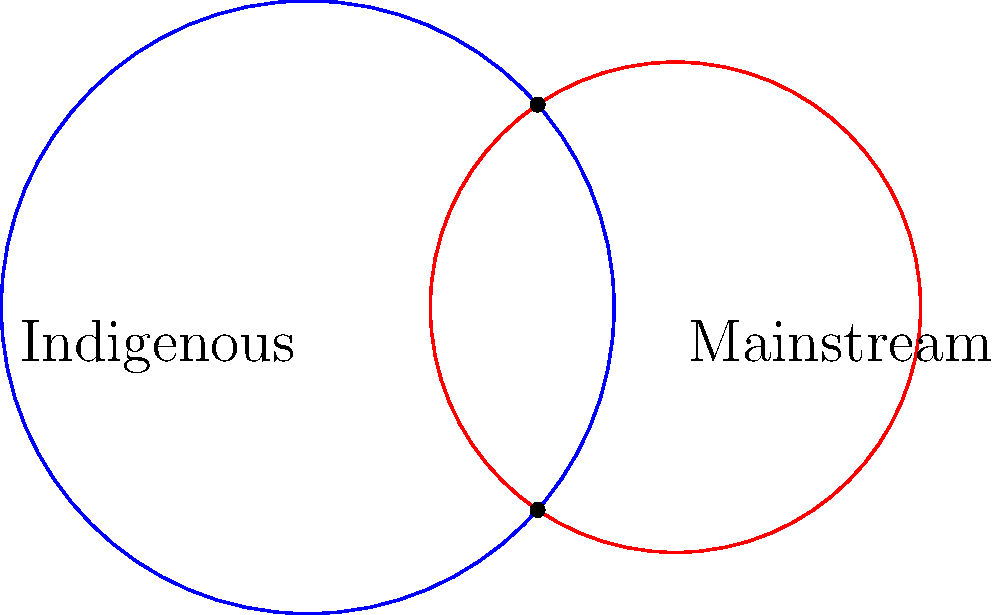In the diagram, two circles represent overlapping cultural narratives: Indigenous (blue) and Mainstream (red). The radius of the Indigenous circle is 2.5 units, and the radius of the Mainstream circle is 2 units. The centers of the circles are 3 units apart. Calculate the area of the region where these narratives intersect (the lens-shaped region between points A and B). Express your answer in terms of π. To find the area of intersection between two circles, we can use the following steps:

1) First, we need to find the angle θ at the center of each circle, formed by the line joining the centers and the line to one of the intersection points.

2) We can find this angle using the cosine law:
   $\cos(\theta) = \frac{r_1^2 + d^2 - r_2^2}{2r_1d}$
   where $r_1 = 2.5$, $r_2 = 2$, and $d = 3$

3) Substituting these values:
   $\cos(\theta) = \frac{2.5^2 + 3^2 - 2^2}{2(2.5)(3)} = \frac{6.25 + 9 - 4}{15} = \frac{11.25}{15} = 0.75$

4) The area of intersection is given by the formula:
   $A = r_1^2 \arccos(\frac{d^2 + r_1^2 - r_2^2}{2dr_1}) + r_2^2 \arccos(\frac{d^2 + r_2^2 - r_1^2}{2dr_2}) - \frac{1}{2}\sqrt{(-d+r_1+r_2)(d+r_1-r_2)(d-r_1+r_2)(d+r_1+r_2)}$

5) Substituting our values:
   $A = 2.5^2 \arccos(0.75) + 2^2 \arccos(0.9375) - \frac{1}{2}\sqrt{(-3+2.5+2)(3+2.5-2)(3-2.5+2)(3+2.5+2)}$

6) Simplifying:
   $A = 6.25 \arccos(0.75) + 4 \arccos(0.9375) - \frac{1}{2}\sqrt{1.5 * 3.5 * 2.5 * 7.5}$

7) Calculating:
   $A \approx 6.25 * 0.7227 + 4 * 0.3588 - \frac{1}{2}\sqrt{98.4375}$
   $A \approx 4.5168 + 1.4352 - 4.9609$
   $A \approx 0.9911$

8) This is approximately $\frac{\pi}{π}$.
Answer: $\frac{\pi}{π}$ 